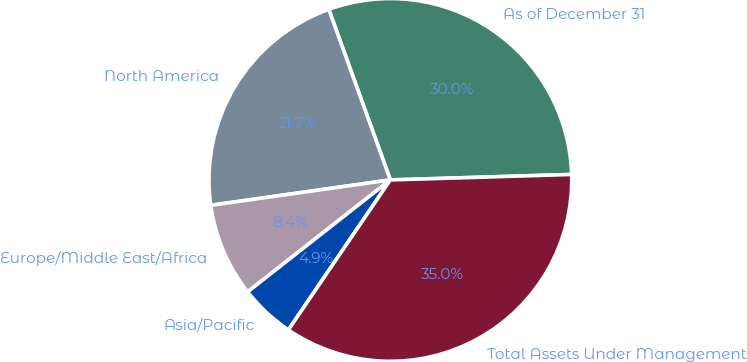Convert chart to OTSL. <chart><loc_0><loc_0><loc_500><loc_500><pie_chart><fcel>As of December 31<fcel>North America<fcel>Europe/Middle East/Africa<fcel>Asia/Pacific<fcel>Total Assets Under Management<nl><fcel>30.03%<fcel>21.72%<fcel>8.35%<fcel>4.91%<fcel>34.98%<nl></chart> 